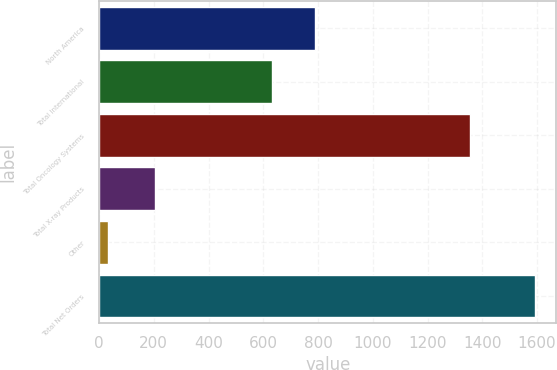<chart> <loc_0><loc_0><loc_500><loc_500><bar_chart><fcel>North America<fcel>Total International<fcel>Total Oncology Systems<fcel>Total X-ray Products<fcel>Other<fcel>Total Net Orders<nl><fcel>788.9<fcel>633<fcel>1355<fcel>204<fcel>32<fcel>1591<nl></chart> 